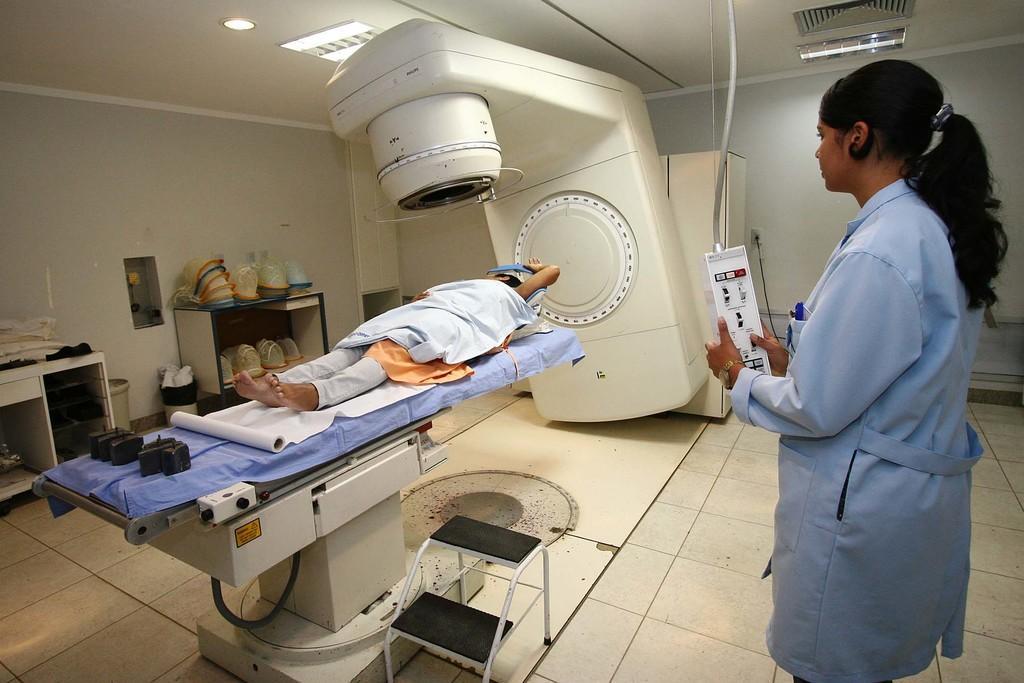Describe this image in one or two sentences. In this image there are two personś one person is lying and the other person is standing and holding an object, there is a white floor,there is light. 